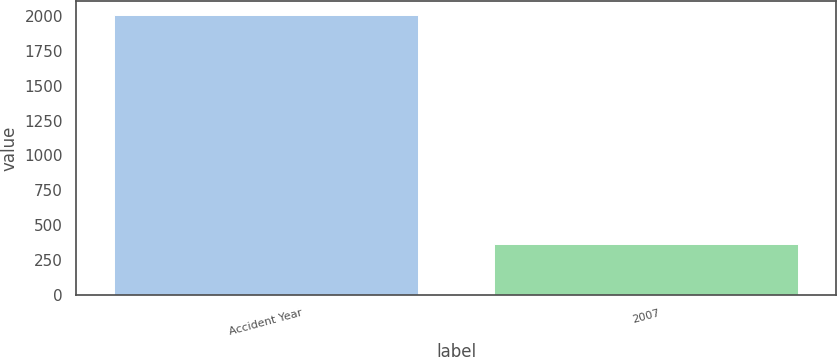<chart> <loc_0><loc_0><loc_500><loc_500><bar_chart><fcel>Accident Year<fcel>2007<nl><fcel>2008<fcel>362<nl></chart> 